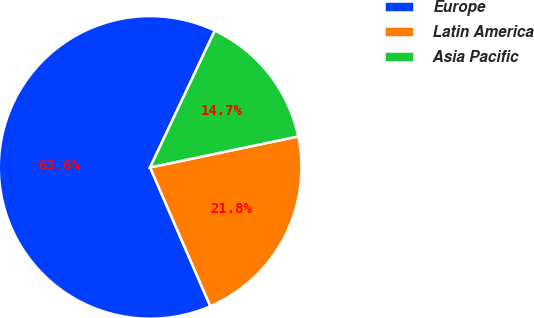<chart> <loc_0><loc_0><loc_500><loc_500><pie_chart><fcel>Europe<fcel>Latin America<fcel>Asia Pacific<nl><fcel>63.55%<fcel>21.77%<fcel>14.68%<nl></chart> 